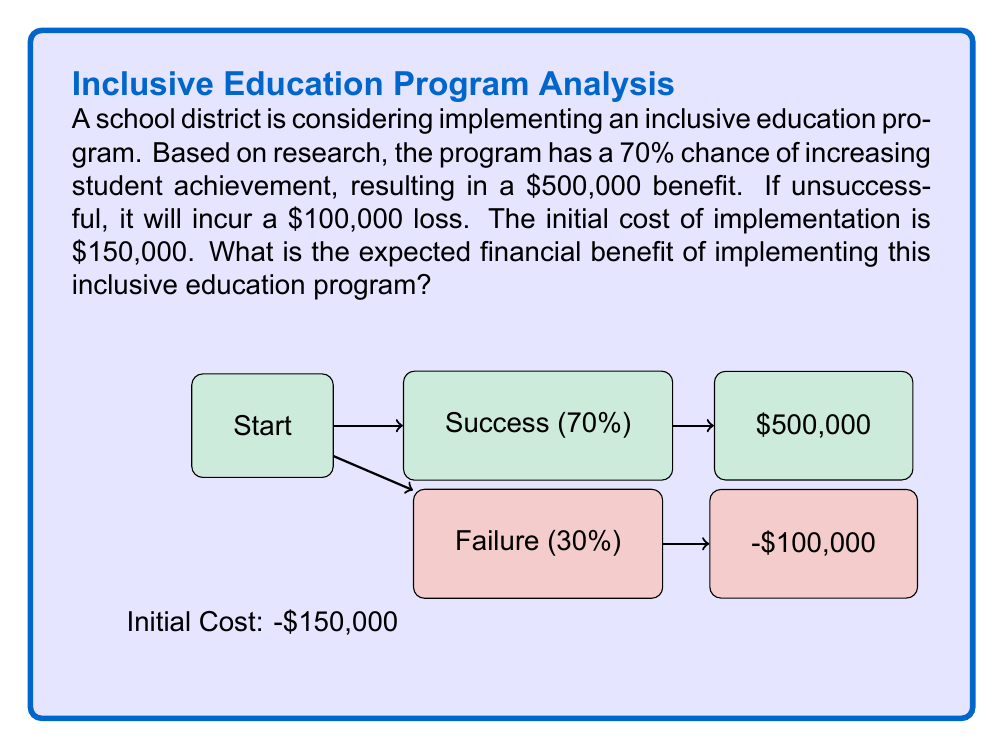Teach me how to tackle this problem. To solve this problem, we'll use the concept of expected value. Let's break it down step-by-step:

1) First, let's calculate the expected value of the program outcomes:

   Success probability: 70% = 0.7
   Failure probability: 30% = 0.3

   Expected Value = (Probability of Success × Benefit) + (Probability of Failure × Loss)
   
   $EV = (0.7 \times \$500,000) + (0.3 \times (-\$100,000))$
   
   $EV = \$350,000 - \$30,000 = \$320,000$

2) Now, we need to account for the initial cost of implementation:

   Net Expected Value = Expected Value - Initial Cost
   
   $NEV = \$320,000 - \$150,000 = \$170,000$

Therefore, the expected financial benefit of implementing the inclusive education program is $170,000.

This positive expected value suggests that, on average, implementing the program would be financially beneficial for the school district, in addition to the potential non-monetary benefits of inclusive education.
Answer: $170,000 